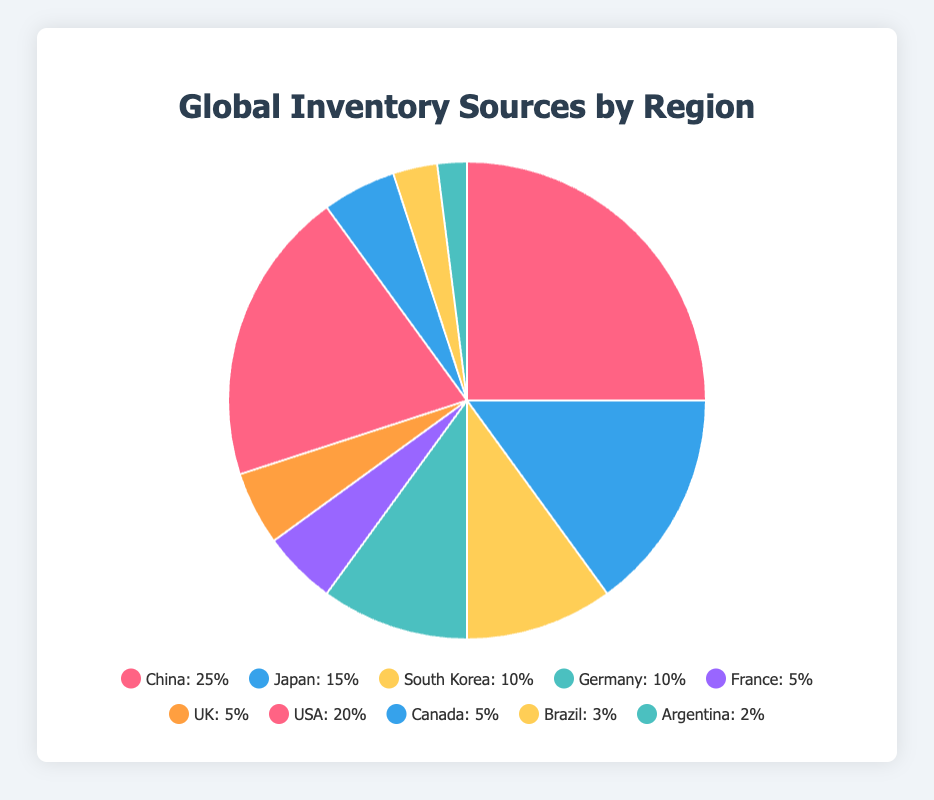Which region has the highest percentage share of inventory sources? The pie chart shows that China has the largest segment, indicating the highest percentage share of inventory sources among all regions. The label for China specifies that its share is 25%.
Answer: Asia (China) What is the total percentage share of all Asian countries combined? Adding up the percentage shares of China (25%), Japan (15%), and South Korea (10%) gives 25 + 15 + 10 = 50%.
Answer: 50% Which two countries contribute an equal percentage share to the inventory sources? The pie chart shows both France and the UK with labels indicating 5% each.
Answer: France and UK Which region has a higher percentage share: North America or Europe? The chart segments for North America (USA 20% and Canada 5%) sum up to 25%, while Europe's segments (Germany 10%, France 5%, UK 5%) sum up to 20%. North America's 25% is greater than Europe's 20%.
Answer: North America How much greater is the USA's share compared to Germany's share? The USA has a 20% share while Germany has a 10% share. The difference is 20 - 10 = 10%.
Answer: 10% What is the combined percentage share of the South American countries? The pie chart shows Brazil with a 3% share and Argentina with a 2% share. Adding these gives 3 + 2 = 5%.
Answer: 5% Which country in Europe has the smallest percentage share? The chart shows that France and the UK have 5% each, both smaller than Germany's 10%. Hence, the smallest share in Europe is divided equally between France and the UK (5% each).
Answer: France and UK Which country has a higher share of inventory sources: Japan or South Korea? The chart indicates Japan with a 15% share and South Korea with a 10% share. 15% is greater than 10%.
Answer: Japan What percentage of inventory sources comes from countries with a primary color in their segments from Asia? The primary colors for Asian segments (red for China, blue for Japan, and yellow for South Korea) indicate respective shares of 25%, 15%, and 10%. Summing these gives 25 + 15 + 10 = 50%.
Answer: 50% Which country has a larger share: Brazil or Canada? The chart indicates Brazil with a 3% share and Canada with a 5% share. 5% is greater than 3%.
Answer: Canada 